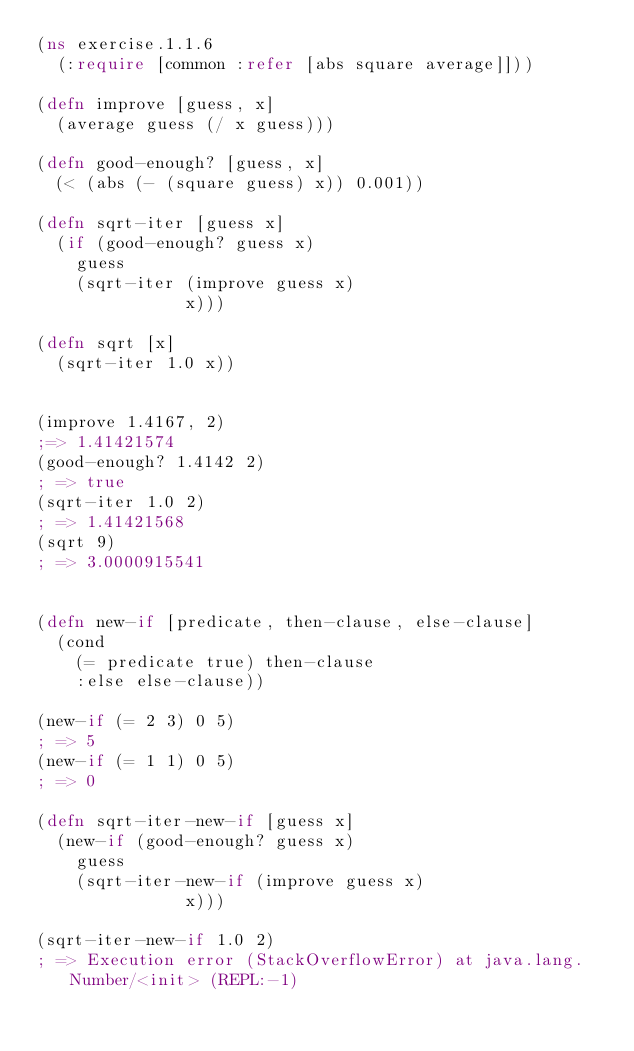<code> <loc_0><loc_0><loc_500><loc_500><_Clojure_>(ns exercise.1.1.6
  (:require [common :refer [abs square average]]))

(defn improve [guess, x]
  (average guess (/ x guess)))

(defn good-enough? [guess, x]
  (< (abs (- (square guess) x)) 0.001))

(defn sqrt-iter [guess x]
  (if (good-enough? guess x)
    guess
    (sqrt-iter (improve guess x)
               x)))

(defn sqrt [x]
  (sqrt-iter 1.0 x))


(improve 1.4167, 2)
;=> 1.41421574
(good-enough? 1.4142 2)
; => true
(sqrt-iter 1.0 2)
; => 1.41421568
(sqrt 9)
; => 3.0000915541


(defn new-if [predicate, then-clause, else-clause]
  (cond
    (= predicate true) then-clause
    :else else-clause))

(new-if (= 2 3) 0 5)
; => 5
(new-if (= 1 1) 0 5)
; => 0

(defn sqrt-iter-new-if [guess x]
  (new-if (good-enough? guess x)
    guess
    (sqrt-iter-new-if (improve guess x)
               x)))

(sqrt-iter-new-if 1.0 2)
; => Execution error (StackOverflowError) at java.lang.Number/<init> (REPL:-1)
</code> 